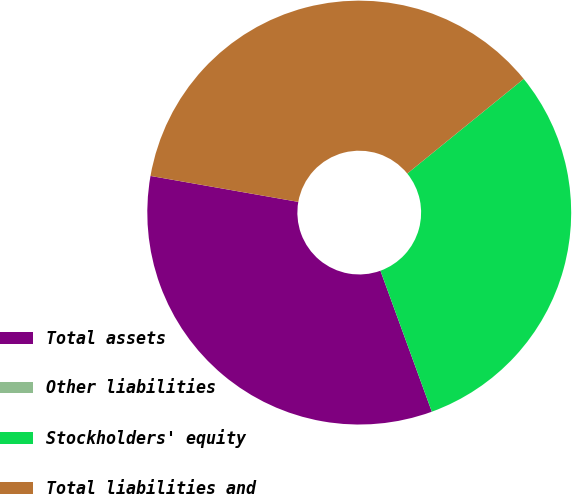Convert chart to OTSL. <chart><loc_0><loc_0><loc_500><loc_500><pie_chart><fcel>Total assets<fcel>Other liabilities<fcel>Stockholders' equity<fcel>Total liabilities and<nl><fcel>33.33%<fcel>0.0%<fcel>30.3%<fcel>36.37%<nl></chart> 